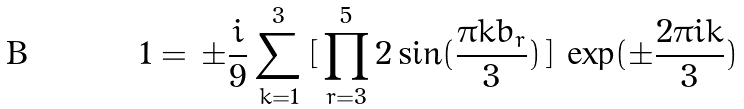Convert formula to latex. <formula><loc_0><loc_0><loc_500><loc_500>1 = \, \pm \frac { i } { 9 } \sum _ { k = 1 } ^ { 3 } \, [ \, \prod _ { r = 3 } ^ { 5 } 2 \sin ( \frac { \pi k b _ { r } } { 3 } ) \, ] \, \exp ( \pm \frac { 2 \pi i k } { 3 } )</formula> 